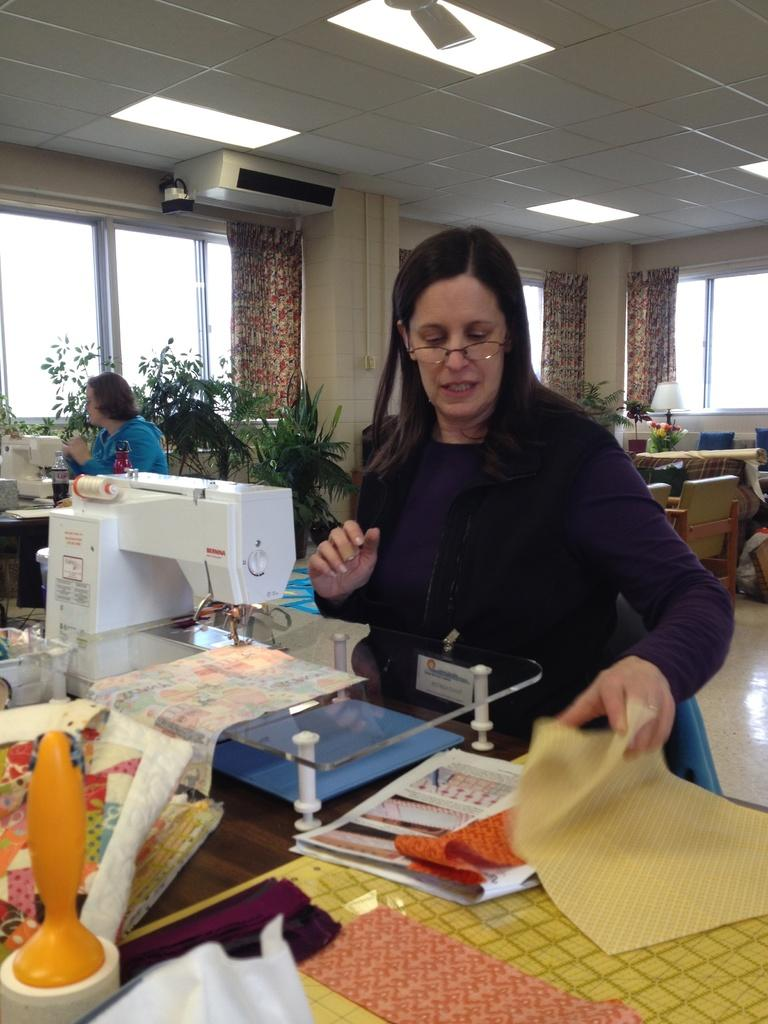How many women are in the room in the image? There are 2 women in the room. What are the women doing in the image? The women are near a stitching machine. What type of plants can be seen in the image? There are water plants visible in the image. What is the source of natural light in the room? There is a window in the room. Is there any window treatment present in the room? Yes, there is a curtain associated with the window. What type of lighting is present in the room? There is a lamp in the room. What type of furniture is present in the room? There is a table and chairs in the room. What can be seen on the roof top in the image? There is an AC and lights on the roof top. What type of corn is being grown in the room in the image? There is no corn present in the image; it features a room with two women near a stitching machine and other objects. 